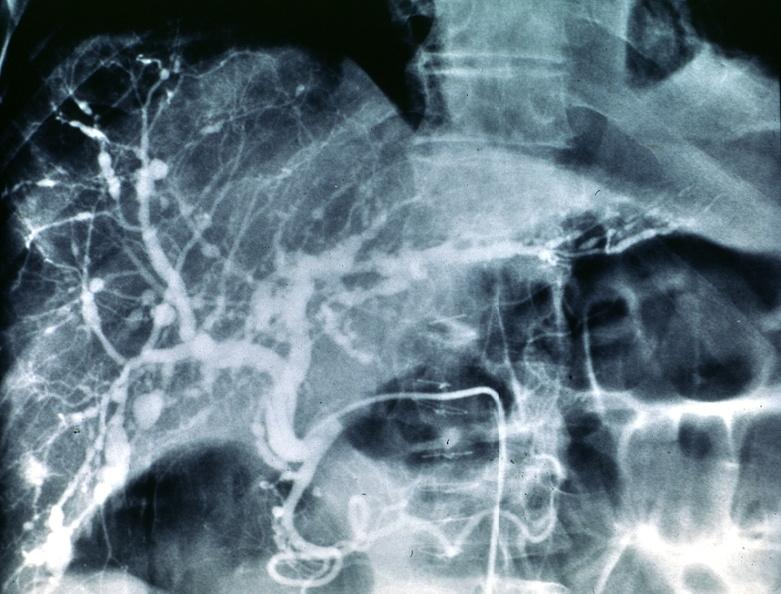does fibrotic lesion show polyarteritis nodosa, liver arteriogram?
Answer the question using a single word or phrase. No 